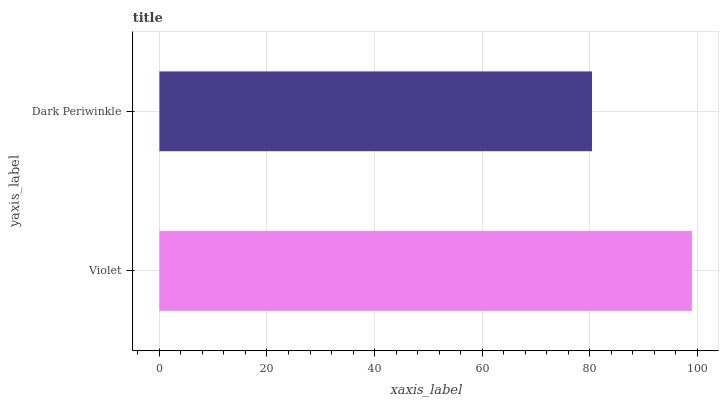Is Dark Periwinkle the minimum?
Answer yes or no. Yes. Is Violet the maximum?
Answer yes or no. Yes. Is Dark Periwinkle the maximum?
Answer yes or no. No. Is Violet greater than Dark Periwinkle?
Answer yes or no. Yes. Is Dark Periwinkle less than Violet?
Answer yes or no. Yes. Is Dark Periwinkle greater than Violet?
Answer yes or no. No. Is Violet less than Dark Periwinkle?
Answer yes or no. No. Is Violet the high median?
Answer yes or no. Yes. Is Dark Periwinkle the low median?
Answer yes or no. Yes. Is Dark Periwinkle the high median?
Answer yes or no. No. Is Violet the low median?
Answer yes or no. No. 